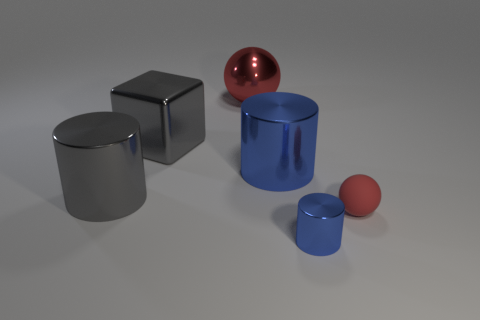Does the red matte object have the same size as the gray metallic cube?
Offer a terse response. No. What size is the other red object that is the same shape as the tiny matte thing?
Offer a terse response. Large. There is a sphere that is in front of the blue shiny object that is behind the tiny blue metal object; what is its material?
Provide a short and direct response. Rubber. Is the shape of the red metallic object the same as the small red thing?
Make the answer very short. Yes. How many shiny objects are both to the left of the big gray shiny block and behind the large cube?
Your answer should be compact. 0. Are there an equal number of tiny rubber balls that are right of the small red matte object and large cylinders that are right of the gray block?
Offer a very short reply. No. Does the blue shiny object that is in front of the tiny red rubber ball have the same size as the metallic thing behind the big metallic cube?
Provide a succinct answer. No. What is the material of the thing that is both right of the red metallic ball and on the left side of the tiny blue metallic cylinder?
Your response must be concise. Metal. What is the size of the sphere in front of the ball behind the tiny red matte object?
Provide a succinct answer. Small. There is a tiny object on the left side of the tiny object on the right side of the tiny blue cylinder in front of the large gray shiny block; what is its shape?
Your response must be concise. Cylinder. 